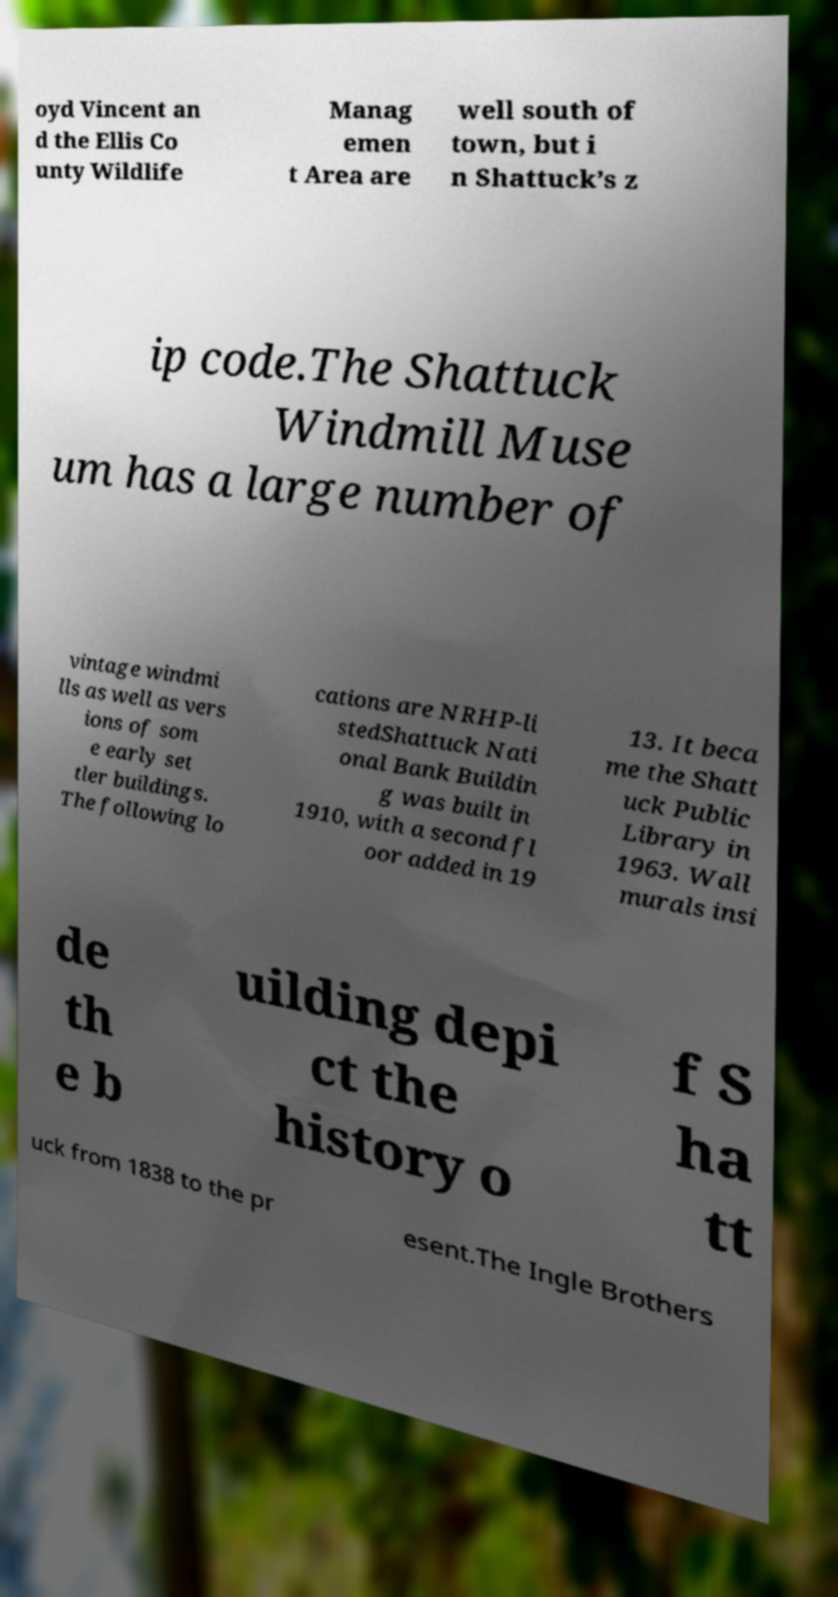For documentation purposes, I need the text within this image transcribed. Could you provide that? oyd Vincent an d the Ellis Co unty Wildlife Manag emen t Area are well south of town, but i n Shattuck’s z ip code.The Shattuck Windmill Muse um has a large number of vintage windmi lls as well as vers ions of som e early set tler buildings. The following lo cations are NRHP-li stedShattuck Nati onal Bank Buildin g was built in 1910, with a second fl oor added in 19 13. It beca me the Shatt uck Public Library in 1963. Wall murals insi de th e b uilding depi ct the history o f S ha tt uck from 1838 to the pr esent.The Ingle Brothers 